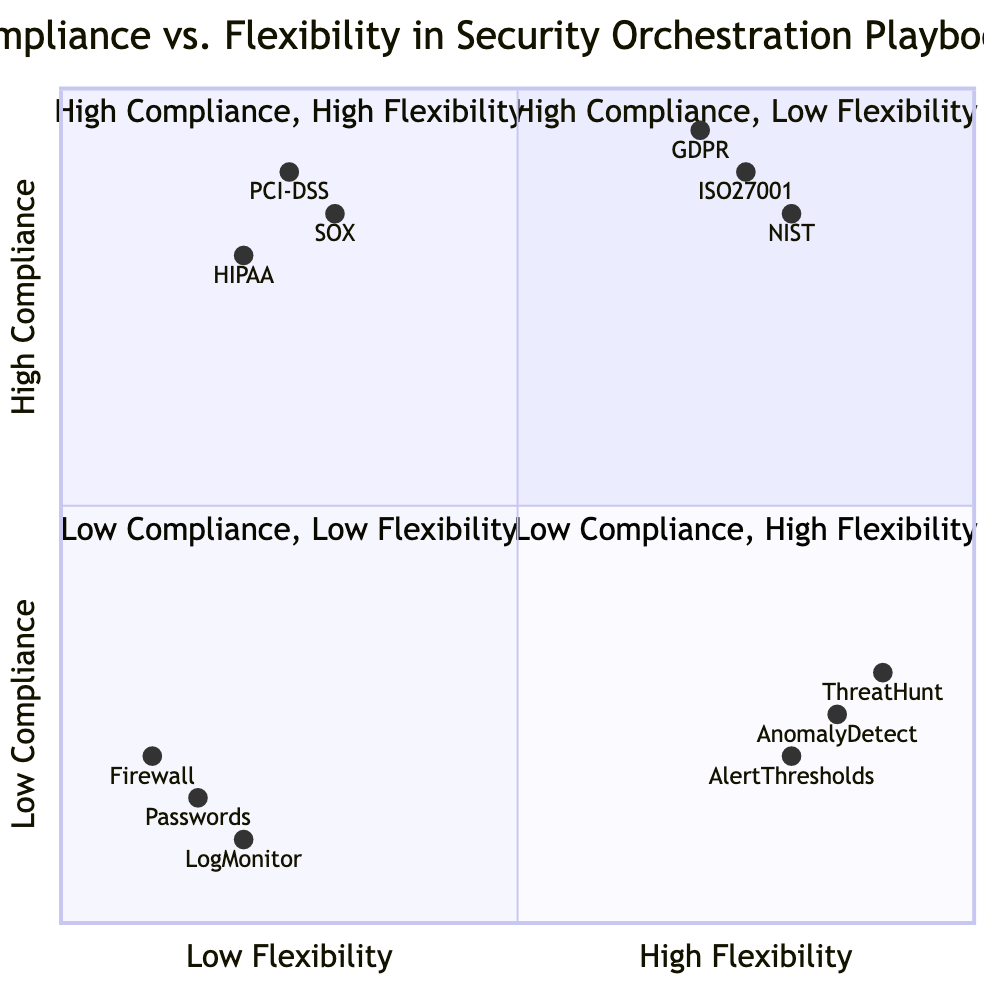What elements are found in the "High Compliance, Low Flexibility" quadrant? The "High Compliance, Low Flexibility" quadrant includes three specific elements: HIPAA-specific Playbooks, SOX Auditing Procedures, and PCI-DSS Risk Assessments.
Answer: HIPAA-specific Playbooks, SOX Auditing Procedures, PCI-DSS Risk Assessments Which quadrant contains "Proactive Threat Hunting"? "Proactive Threat Hunting" is located in the "Low Compliance, High Flexibility" quadrant, which is the bottom-right section of the quadrant chart.
Answer: Low Compliance, High Flexibility How many elements are in the "Low Compliance, Low Flexibility" quadrant? The "Low Compliance, Low Flexibility" quadrant has three elements: Basic Firewall Configurations, Static Password Policies, and Manual Log Monitoring, making a total of three.
Answer: 3 Which element has the highest flexibility among those listed? "Proactive Threat Hunting" is noted as the element with the highest flexibility, situated in the "Low Compliance, High Flexibility" quadrant.
Answer: Proactive Threat Hunting What is the compliance level for "NIST 800-53 Automated Controls Testing"? The compliance level for "NIST 800-53 Automated Controls Testing" is high, as it appears in the "High Compliance, High Flexibility" quadrant.
Answer: High Which quadrant has the element "Static Password Policies"? "Static Password Policies" is classified under the "Low Compliance, Low Flexibility" quadrant, which is positioned at the bottom-left of the chart.
Answer: Low Compliance, Low Flexibility What do the elements in the "High Compliance, High Flexibility" quadrant focus on? The elements in the "High Compliance, High Flexibility" quadrant focus on compliance-driven activities that also allow for automated and integrated responses, such as GDPR Incident Response Team Coordination, showcasing both aspects of compliance and flexibility.
Answer: Compliance-driven activities with automation Identify one element that resides in the "Top-Right" quadrant. One element located in the "Top-Right" quadrant, which represents high compliance and high flexibility, is "NIST 800-53 Automated Controls Testing."
Answer: NIST 800-53 Automated Controls Testing Which quadrant is more suited for adaptability in security orchestration playbooks? The "Low Compliance, High Flexibility" quadrant is better suited for adaptability as it includes elements that allow for greater customization and dynamic responses.
Answer: Low Compliance, High Flexibility 